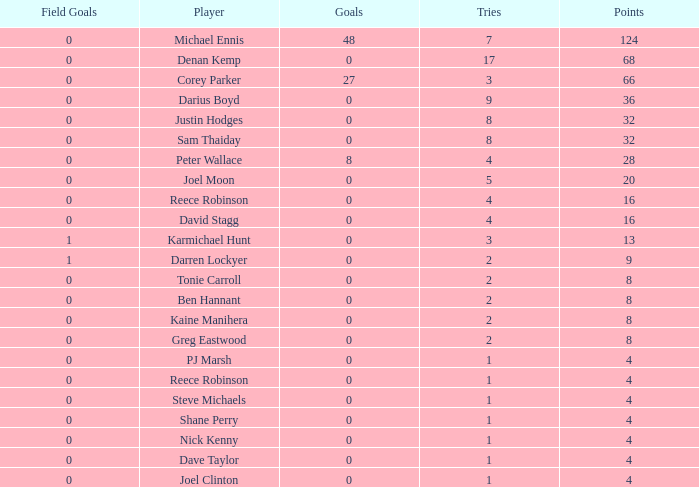What is the number of goals Dave Taylor, who has more than 1 tries, has? None. 